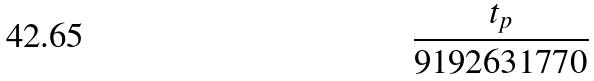Convert formula to latex. <formula><loc_0><loc_0><loc_500><loc_500>\frac { t _ { p } } { 9 1 9 2 6 3 1 7 7 0 }</formula> 